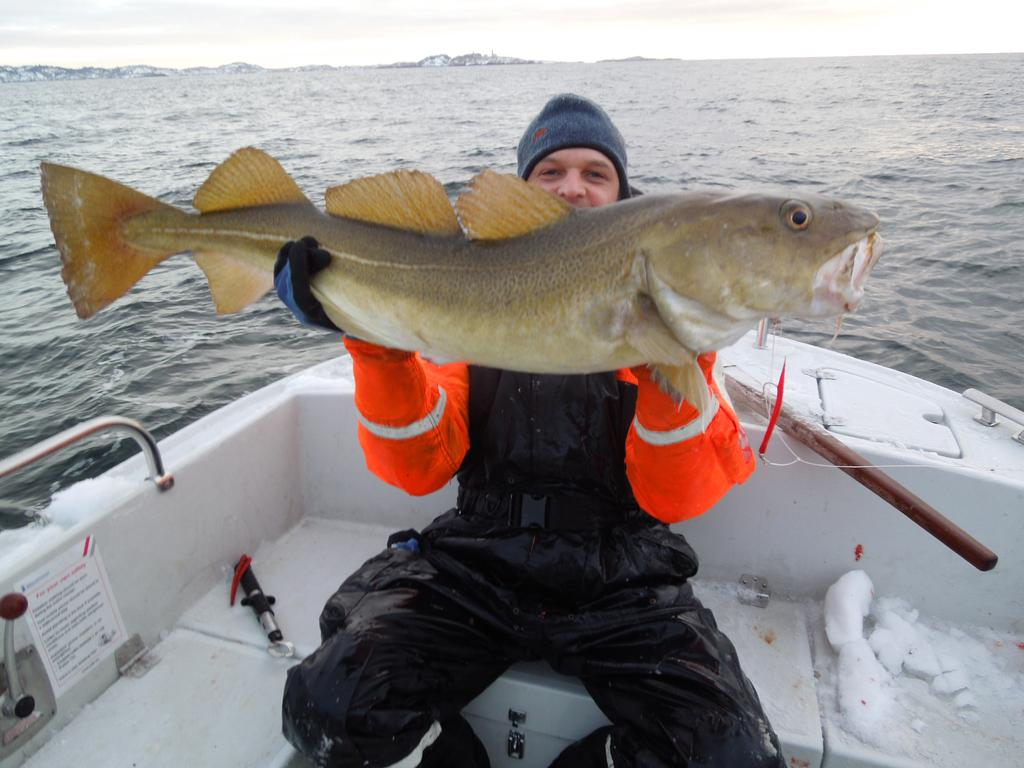What is the person in the image doing? The person is sitting on a boat in the image. What protective gear is the person wearing? The person is wearing a safety jacket, gloves, and a cap. What is the person holding in the image? The person is holding a fish. What can be seen in the background of the image? There is water visible in the background of the image. What type of earth can be seen in the image? There is no earth visible in the image; it features a person sitting on a boat in water. Are there any police officers present in the image? There are no police officers present in the image. 